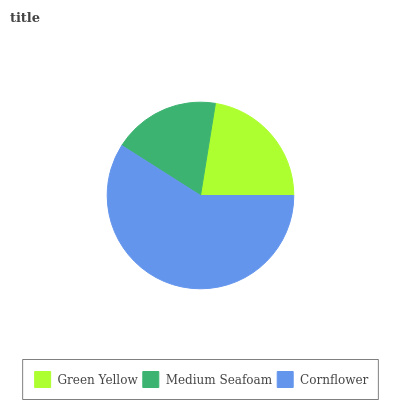Is Medium Seafoam the minimum?
Answer yes or no. Yes. Is Cornflower the maximum?
Answer yes or no. Yes. Is Cornflower the minimum?
Answer yes or no. No. Is Medium Seafoam the maximum?
Answer yes or no. No. Is Cornflower greater than Medium Seafoam?
Answer yes or no. Yes. Is Medium Seafoam less than Cornflower?
Answer yes or no. Yes. Is Medium Seafoam greater than Cornflower?
Answer yes or no. No. Is Cornflower less than Medium Seafoam?
Answer yes or no. No. Is Green Yellow the high median?
Answer yes or no. Yes. Is Green Yellow the low median?
Answer yes or no. Yes. Is Medium Seafoam the high median?
Answer yes or no. No. Is Medium Seafoam the low median?
Answer yes or no. No. 